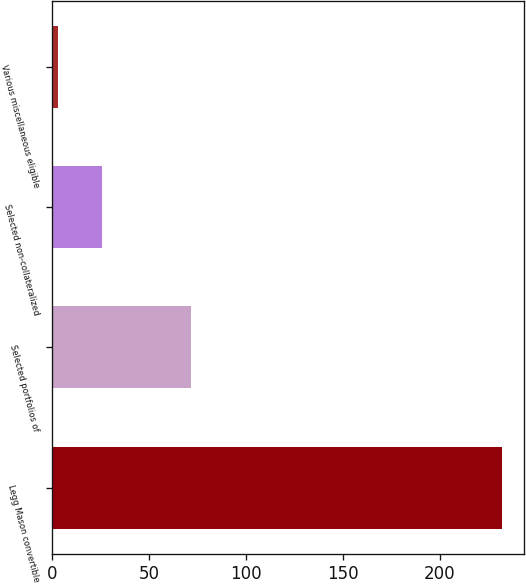<chart> <loc_0><loc_0><loc_500><loc_500><bar_chart><fcel>Legg Mason convertible<fcel>Selected portfolios of<fcel>Selected non-collateralized<fcel>Various miscellaneous eligible<nl><fcel>232<fcel>71.7<fcel>25.9<fcel>3<nl></chart> 